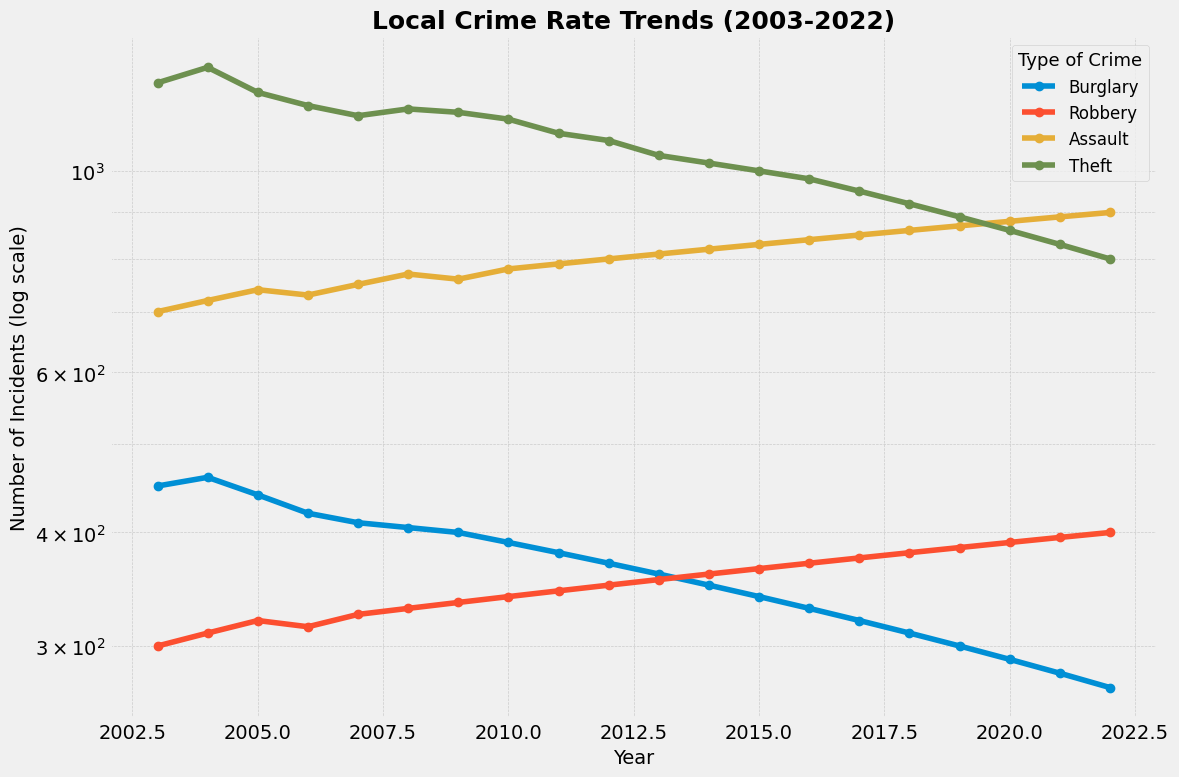How has the number of burglaries changed from 2003 to 2022? To find this out, look at the y-values for the ‘Burglary’ line at the start and end of the plotted range. In 2003, there were 450 burglaries, and in 2022, there were 270 burglaries. The change is 450 - 270.
Answer: 180 Between which two consecutive years did the number of theft incidents show the greatest decrease? Notice that the number of theft incidents (green line) changes every year. Compare the differences: the largest decrease is from 2010 to 2011, where the value dropped from 1140 to 1100. The difference is 40.
Answer: 2010-2011 Which year had the highest number of robbery incidents? Look at the 'Robbery' line and identify the highest point. The highest number is 400, which occurred in 2022.
Answer: 2022 What is the average number of assault incidents over the last five years? Take the 'Assault' values from 2018 to 2022 and find the average: (860 + 870 + 880 + 890 + 900) / 5 = 880.
Answer: 880 Which type of crime consistently decreases over the time period? Observe each line in the plot to see if it trends downwards consistently from 2003 to 2022. The 'Burglary' incidents show a consistent decrease.
Answer: Burglary What’s the difference in the number of assault incidents between 2012 and 2022? Find the 'Assault' number in 2012 and 2022, then subtract. In 2012, there were 800, and in 2022, there were 900, so the difference is 900 - 800.
Answer: 100 Which crime type had the smallest number of incidents in 2010? Look at the y-values for the year 2010 and compare between the crime types. 'Burglary' had the smallest number of incidents, which is 390.
Answer: Burglary On a logarithmic scale, which type of crime has the steepest decline? Visually inspect the lines on the log-scale plot. The ‘Burglary’ line has the steepest decline.
Answer: Burglary What’s the overall trend for robbery incidents from 2003 to 2022? Observe the 'Robbery' line from 2003 to 2022 to determine its general direction. Robbery incidents gradually increase over time.
Answer: Increasing Across all years, which crime type has the most stable trend? Visually check which line changes the least in terms of slope. The 'Assault' line appears to have the most stable trend over the years.
Answer: Assault 